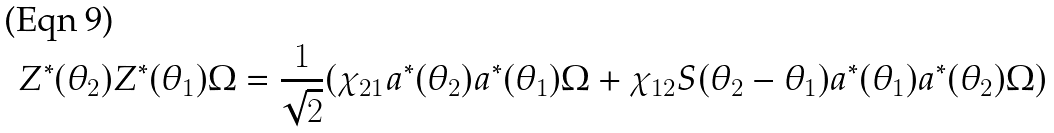<formula> <loc_0><loc_0><loc_500><loc_500>Z ^ { \ast } ( \theta _ { 2 } ) Z ^ { \ast } ( \theta _ { 1 } ) \Omega = \frac { 1 } { \sqrt { 2 } } ( \chi _ { 2 1 } a ^ { \ast } ( \theta _ { 2 } ) a ^ { \ast } ( \theta _ { 1 } ) \Omega + \chi _ { 1 2 } S ( \theta _ { 2 } - \theta _ { 1 } ) a ^ { \ast } ( \theta _ { 1 } ) a ^ { \ast } ( \theta _ { 2 } ) \Omega )</formula> 